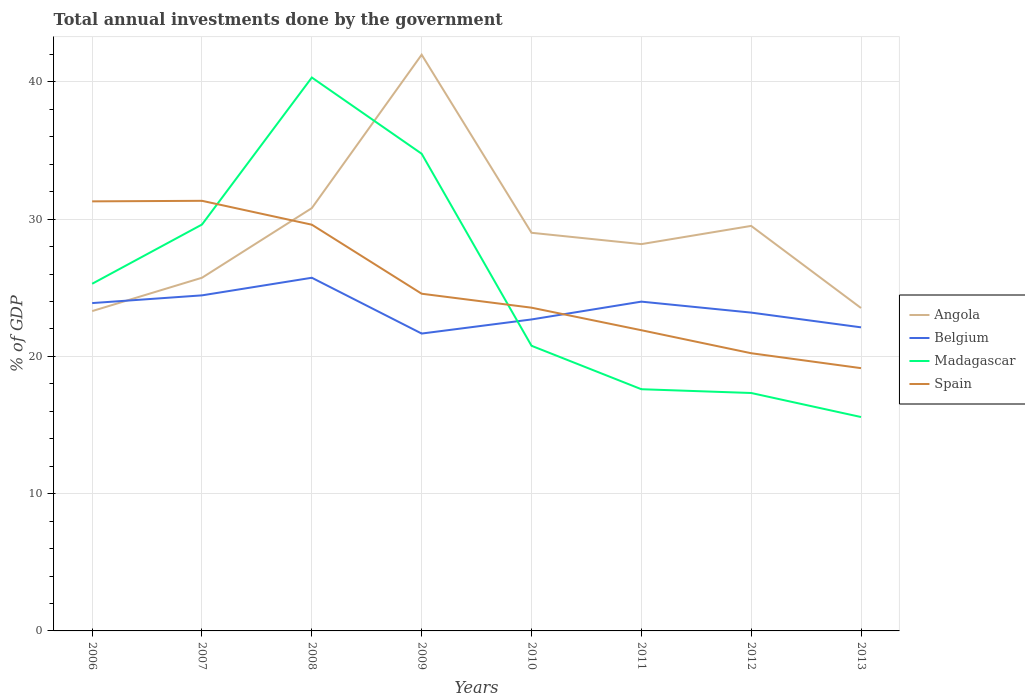How many different coloured lines are there?
Your answer should be compact. 4. Across all years, what is the maximum total annual investments done by the government in Belgium?
Offer a terse response. 21.66. In which year was the total annual investments done by the government in Belgium maximum?
Your answer should be compact. 2009. What is the total total annual investments done by the government in Belgium in the graph?
Make the answer very short. -0.45. What is the difference between the highest and the second highest total annual investments done by the government in Angola?
Your answer should be compact. 18.68. Is the total annual investments done by the government in Belgium strictly greater than the total annual investments done by the government in Spain over the years?
Provide a short and direct response. No. Are the values on the major ticks of Y-axis written in scientific E-notation?
Keep it short and to the point. No. Where does the legend appear in the graph?
Provide a short and direct response. Center right. How many legend labels are there?
Ensure brevity in your answer.  4. What is the title of the graph?
Your answer should be very brief. Total annual investments done by the government. Does "Cambodia" appear as one of the legend labels in the graph?
Provide a succinct answer. No. What is the label or title of the Y-axis?
Ensure brevity in your answer.  % of GDP. What is the % of GDP of Angola in 2006?
Give a very brief answer. 23.3. What is the % of GDP of Belgium in 2006?
Make the answer very short. 23.88. What is the % of GDP of Madagascar in 2006?
Your response must be concise. 25.29. What is the % of GDP of Spain in 2006?
Provide a succinct answer. 31.3. What is the % of GDP of Angola in 2007?
Your response must be concise. 25.73. What is the % of GDP in Belgium in 2007?
Make the answer very short. 24.45. What is the % of GDP of Madagascar in 2007?
Provide a short and direct response. 29.61. What is the % of GDP of Spain in 2007?
Provide a short and direct response. 31.34. What is the % of GDP in Angola in 2008?
Ensure brevity in your answer.  30.8. What is the % of GDP in Belgium in 2008?
Give a very brief answer. 25.73. What is the % of GDP of Madagascar in 2008?
Keep it short and to the point. 40.32. What is the % of GDP of Spain in 2008?
Give a very brief answer. 29.6. What is the % of GDP in Angola in 2009?
Your answer should be very brief. 41.98. What is the % of GDP in Belgium in 2009?
Offer a very short reply. 21.66. What is the % of GDP in Madagascar in 2009?
Your answer should be compact. 34.76. What is the % of GDP of Spain in 2009?
Ensure brevity in your answer.  24.57. What is the % of GDP in Angola in 2010?
Your answer should be compact. 29.01. What is the % of GDP of Belgium in 2010?
Ensure brevity in your answer.  22.69. What is the % of GDP of Madagascar in 2010?
Your answer should be very brief. 20.77. What is the % of GDP of Spain in 2010?
Your answer should be very brief. 23.55. What is the % of GDP of Angola in 2011?
Your response must be concise. 28.18. What is the % of GDP of Belgium in 2011?
Offer a very short reply. 23.99. What is the % of GDP of Madagascar in 2011?
Your response must be concise. 17.61. What is the % of GDP in Spain in 2011?
Your answer should be very brief. 21.91. What is the % of GDP in Angola in 2012?
Give a very brief answer. 29.51. What is the % of GDP in Belgium in 2012?
Ensure brevity in your answer.  23.19. What is the % of GDP of Madagascar in 2012?
Offer a terse response. 17.33. What is the % of GDP in Spain in 2012?
Offer a terse response. 20.23. What is the % of GDP of Angola in 2013?
Ensure brevity in your answer.  23.53. What is the % of GDP in Belgium in 2013?
Your response must be concise. 22.12. What is the % of GDP of Madagascar in 2013?
Your response must be concise. 15.58. What is the % of GDP of Spain in 2013?
Give a very brief answer. 19.14. Across all years, what is the maximum % of GDP of Angola?
Your response must be concise. 41.98. Across all years, what is the maximum % of GDP in Belgium?
Keep it short and to the point. 25.73. Across all years, what is the maximum % of GDP of Madagascar?
Ensure brevity in your answer.  40.32. Across all years, what is the maximum % of GDP in Spain?
Provide a short and direct response. 31.34. Across all years, what is the minimum % of GDP in Angola?
Your answer should be compact. 23.3. Across all years, what is the minimum % of GDP in Belgium?
Give a very brief answer. 21.66. Across all years, what is the minimum % of GDP of Madagascar?
Offer a very short reply. 15.58. Across all years, what is the minimum % of GDP in Spain?
Make the answer very short. 19.14. What is the total % of GDP of Angola in the graph?
Ensure brevity in your answer.  232.04. What is the total % of GDP in Belgium in the graph?
Your answer should be very brief. 187.72. What is the total % of GDP in Madagascar in the graph?
Make the answer very short. 201.28. What is the total % of GDP in Spain in the graph?
Give a very brief answer. 201.63. What is the difference between the % of GDP of Angola in 2006 and that in 2007?
Make the answer very short. -2.43. What is the difference between the % of GDP in Belgium in 2006 and that in 2007?
Offer a very short reply. -0.56. What is the difference between the % of GDP in Madagascar in 2006 and that in 2007?
Provide a succinct answer. -4.32. What is the difference between the % of GDP in Spain in 2006 and that in 2007?
Keep it short and to the point. -0.04. What is the difference between the % of GDP of Angola in 2006 and that in 2008?
Your response must be concise. -7.5. What is the difference between the % of GDP in Belgium in 2006 and that in 2008?
Provide a succinct answer. -1.85. What is the difference between the % of GDP in Madagascar in 2006 and that in 2008?
Provide a succinct answer. -15.03. What is the difference between the % of GDP in Spain in 2006 and that in 2008?
Offer a terse response. 1.7. What is the difference between the % of GDP of Angola in 2006 and that in 2009?
Keep it short and to the point. -18.68. What is the difference between the % of GDP in Belgium in 2006 and that in 2009?
Make the answer very short. 2.22. What is the difference between the % of GDP of Madagascar in 2006 and that in 2009?
Offer a terse response. -9.47. What is the difference between the % of GDP of Spain in 2006 and that in 2009?
Make the answer very short. 6.73. What is the difference between the % of GDP of Angola in 2006 and that in 2010?
Provide a succinct answer. -5.7. What is the difference between the % of GDP in Belgium in 2006 and that in 2010?
Keep it short and to the point. 1.19. What is the difference between the % of GDP in Madagascar in 2006 and that in 2010?
Keep it short and to the point. 4.52. What is the difference between the % of GDP in Spain in 2006 and that in 2010?
Your answer should be compact. 7.75. What is the difference between the % of GDP in Angola in 2006 and that in 2011?
Make the answer very short. -4.88. What is the difference between the % of GDP of Belgium in 2006 and that in 2011?
Provide a succinct answer. -0.11. What is the difference between the % of GDP of Madagascar in 2006 and that in 2011?
Make the answer very short. 7.68. What is the difference between the % of GDP of Spain in 2006 and that in 2011?
Give a very brief answer. 9.39. What is the difference between the % of GDP of Angola in 2006 and that in 2012?
Offer a terse response. -6.21. What is the difference between the % of GDP of Belgium in 2006 and that in 2012?
Provide a short and direct response. 0.69. What is the difference between the % of GDP in Madagascar in 2006 and that in 2012?
Provide a succinct answer. 7.96. What is the difference between the % of GDP of Spain in 2006 and that in 2012?
Keep it short and to the point. 11.06. What is the difference between the % of GDP in Angola in 2006 and that in 2013?
Offer a very short reply. -0.22. What is the difference between the % of GDP in Belgium in 2006 and that in 2013?
Give a very brief answer. 1.77. What is the difference between the % of GDP of Madagascar in 2006 and that in 2013?
Your answer should be very brief. 9.71. What is the difference between the % of GDP of Spain in 2006 and that in 2013?
Offer a very short reply. 12.15. What is the difference between the % of GDP of Angola in 2007 and that in 2008?
Give a very brief answer. -5.07. What is the difference between the % of GDP of Belgium in 2007 and that in 2008?
Give a very brief answer. -1.28. What is the difference between the % of GDP of Madagascar in 2007 and that in 2008?
Ensure brevity in your answer.  -10.71. What is the difference between the % of GDP in Spain in 2007 and that in 2008?
Offer a terse response. 1.74. What is the difference between the % of GDP in Angola in 2007 and that in 2009?
Ensure brevity in your answer.  -16.25. What is the difference between the % of GDP of Belgium in 2007 and that in 2009?
Offer a terse response. 2.78. What is the difference between the % of GDP in Madagascar in 2007 and that in 2009?
Offer a very short reply. -5.16. What is the difference between the % of GDP of Spain in 2007 and that in 2009?
Offer a terse response. 6.77. What is the difference between the % of GDP in Angola in 2007 and that in 2010?
Your answer should be compact. -3.27. What is the difference between the % of GDP of Belgium in 2007 and that in 2010?
Your answer should be compact. 1.76. What is the difference between the % of GDP in Madagascar in 2007 and that in 2010?
Offer a very short reply. 8.83. What is the difference between the % of GDP of Spain in 2007 and that in 2010?
Provide a succinct answer. 7.79. What is the difference between the % of GDP of Angola in 2007 and that in 2011?
Make the answer very short. -2.45. What is the difference between the % of GDP of Belgium in 2007 and that in 2011?
Keep it short and to the point. 0.46. What is the difference between the % of GDP of Madagascar in 2007 and that in 2011?
Provide a succinct answer. 12. What is the difference between the % of GDP in Spain in 2007 and that in 2011?
Ensure brevity in your answer.  9.43. What is the difference between the % of GDP in Angola in 2007 and that in 2012?
Keep it short and to the point. -3.78. What is the difference between the % of GDP in Belgium in 2007 and that in 2012?
Keep it short and to the point. 1.26. What is the difference between the % of GDP of Madagascar in 2007 and that in 2012?
Provide a short and direct response. 12.27. What is the difference between the % of GDP in Spain in 2007 and that in 2012?
Provide a short and direct response. 11.1. What is the difference between the % of GDP in Angola in 2007 and that in 2013?
Offer a terse response. 2.21. What is the difference between the % of GDP of Belgium in 2007 and that in 2013?
Provide a short and direct response. 2.33. What is the difference between the % of GDP in Madagascar in 2007 and that in 2013?
Your response must be concise. 14.02. What is the difference between the % of GDP in Spain in 2007 and that in 2013?
Provide a succinct answer. 12.19. What is the difference between the % of GDP of Angola in 2008 and that in 2009?
Give a very brief answer. -11.18. What is the difference between the % of GDP in Belgium in 2008 and that in 2009?
Keep it short and to the point. 4.07. What is the difference between the % of GDP of Madagascar in 2008 and that in 2009?
Your response must be concise. 5.55. What is the difference between the % of GDP of Spain in 2008 and that in 2009?
Your answer should be compact. 5.03. What is the difference between the % of GDP in Angola in 2008 and that in 2010?
Ensure brevity in your answer.  1.8. What is the difference between the % of GDP of Belgium in 2008 and that in 2010?
Offer a terse response. 3.04. What is the difference between the % of GDP of Madagascar in 2008 and that in 2010?
Provide a succinct answer. 19.54. What is the difference between the % of GDP in Spain in 2008 and that in 2010?
Your answer should be compact. 6.05. What is the difference between the % of GDP of Angola in 2008 and that in 2011?
Make the answer very short. 2.62. What is the difference between the % of GDP in Belgium in 2008 and that in 2011?
Your answer should be very brief. 1.74. What is the difference between the % of GDP of Madagascar in 2008 and that in 2011?
Keep it short and to the point. 22.71. What is the difference between the % of GDP in Spain in 2008 and that in 2011?
Provide a succinct answer. 7.69. What is the difference between the % of GDP in Angola in 2008 and that in 2012?
Provide a short and direct response. 1.3. What is the difference between the % of GDP of Belgium in 2008 and that in 2012?
Give a very brief answer. 2.54. What is the difference between the % of GDP of Madagascar in 2008 and that in 2012?
Your response must be concise. 22.98. What is the difference between the % of GDP in Spain in 2008 and that in 2012?
Provide a succinct answer. 9.36. What is the difference between the % of GDP of Angola in 2008 and that in 2013?
Offer a very short reply. 7.28. What is the difference between the % of GDP in Belgium in 2008 and that in 2013?
Give a very brief answer. 3.61. What is the difference between the % of GDP of Madagascar in 2008 and that in 2013?
Provide a short and direct response. 24.73. What is the difference between the % of GDP of Spain in 2008 and that in 2013?
Offer a terse response. 10.45. What is the difference between the % of GDP in Angola in 2009 and that in 2010?
Offer a terse response. 12.98. What is the difference between the % of GDP in Belgium in 2009 and that in 2010?
Your answer should be compact. -1.03. What is the difference between the % of GDP in Madagascar in 2009 and that in 2010?
Your answer should be very brief. 13.99. What is the difference between the % of GDP in Spain in 2009 and that in 2010?
Offer a terse response. 1.02. What is the difference between the % of GDP of Angola in 2009 and that in 2011?
Your answer should be very brief. 13.8. What is the difference between the % of GDP in Belgium in 2009 and that in 2011?
Your answer should be compact. -2.33. What is the difference between the % of GDP in Madagascar in 2009 and that in 2011?
Give a very brief answer. 17.16. What is the difference between the % of GDP in Spain in 2009 and that in 2011?
Ensure brevity in your answer.  2.66. What is the difference between the % of GDP of Angola in 2009 and that in 2012?
Provide a short and direct response. 12.47. What is the difference between the % of GDP of Belgium in 2009 and that in 2012?
Keep it short and to the point. -1.53. What is the difference between the % of GDP in Madagascar in 2009 and that in 2012?
Offer a terse response. 17.43. What is the difference between the % of GDP in Spain in 2009 and that in 2012?
Make the answer very short. 4.33. What is the difference between the % of GDP in Angola in 2009 and that in 2013?
Give a very brief answer. 18.46. What is the difference between the % of GDP in Belgium in 2009 and that in 2013?
Keep it short and to the point. -0.45. What is the difference between the % of GDP in Madagascar in 2009 and that in 2013?
Your response must be concise. 19.18. What is the difference between the % of GDP in Spain in 2009 and that in 2013?
Ensure brevity in your answer.  5.42. What is the difference between the % of GDP of Angola in 2010 and that in 2011?
Your answer should be very brief. 0.83. What is the difference between the % of GDP in Belgium in 2010 and that in 2011?
Offer a terse response. -1.3. What is the difference between the % of GDP in Madagascar in 2010 and that in 2011?
Offer a very short reply. 3.17. What is the difference between the % of GDP of Spain in 2010 and that in 2011?
Your answer should be very brief. 1.64. What is the difference between the % of GDP in Angola in 2010 and that in 2012?
Provide a short and direct response. -0.5. What is the difference between the % of GDP of Belgium in 2010 and that in 2012?
Provide a short and direct response. -0.5. What is the difference between the % of GDP of Madagascar in 2010 and that in 2012?
Give a very brief answer. 3.44. What is the difference between the % of GDP in Spain in 2010 and that in 2012?
Offer a very short reply. 3.32. What is the difference between the % of GDP in Angola in 2010 and that in 2013?
Make the answer very short. 5.48. What is the difference between the % of GDP in Belgium in 2010 and that in 2013?
Make the answer very short. 0.57. What is the difference between the % of GDP of Madagascar in 2010 and that in 2013?
Ensure brevity in your answer.  5.19. What is the difference between the % of GDP of Spain in 2010 and that in 2013?
Your response must be concise. 4.41. What is the difference between the % of GDP of Angola in 2011 and that in 2012?
Your answer should be compact. -1.33. What is the difference between the % of GDP in Belgium in 2011 and that in 2012?
Provide a short and direct response. 0.8. What is the difference between the % of GDP in Madagascar in 2011 and that in 2012?
Keep it short and to the point. 0.28. What is the difference between the % of GDP in Spain in 2011 and that in 2012?
Offer a terse response. 1.68. What is the difference between the % of GDP in Angola in 2011 and that in 2013?
Offer a terse response. 4.65. What is the difference between the % of GDP in Belgium in 2011 and that in 2013?
Your answer should be very brief. 1.87. What is the difference between the % of GDP of Madagascar in 2011 and that in 2013?
Offer a very short reply. 2.03. What is the difference between the % of GDP of Spain in 2011 and that in 2013?
Give a very brief answer. 2.76. What is the difference between the % of GDP of Angola in 2012 and that in 2013?
Ensure brevity in your answer.  5.98. What is the difference between the % of GDP of Belgium in 2012 and that in 2013?
Make the answer very short. 1.07. What is the difference between the % of GDP of Madagascar in 2012 and that in 2013?
Give a very brief answer. 1.75. What is the difference between the % of GDP in Spain in 2012 and that in 2013?
Your answer should be very brief. 1.09. What is the difference between the % of GDP of Angola in 2006 and the % of GDP of Belgium in 2007?
Ensure brevity in your answer.  -1.15. What is the difference between the % of GDP of Angola in 2006 and the % of GDP of Madagascar in 2007?
Your answer should be compact. -6.31. What is the difference between the % of GDP in Angola in 2006 and the % of GDP in Spain in 2007?
Your answer should be very brief. -8.03. What is the difference between the % of GDP of Belgium in 2006 and the % of GDP of Madagascar in 2007?
Give a very brief answer. -5.72. What is the difference between the % of GDP of Belgium in 2006 and the % of GDP of Spain in 2007?
Your response must be concise. -7.45. What is the difference between the % of GDP of Madagascar in 2006 and the % of GDP of Spain in 2007?
Keep it short and to the point. -6.04. What is the difference between the % of GDP of Angola in 2006 and the % of GDP of Belgium in 2008?
Keep it short and to the point. -2.43. What is the difference between the % of GDP of Angola in 2006 and the % of GDP of Madagascar in 2008?
Provide a succinct answer. -17.02. What is the difference between the % of GDP of Angola in 2006 and the % of GDP of Spain in 2008?
Your response must be concise. -6.3. What is the difference between the % of GDP in Belgium in 2006 and the % of GDP in Madagascar in 2008?
Your answer should be very brief. -16.43. What is the difference between the % of GDP of Belgium in 2006 and the % of GDP of Spain in 2008?
Offer a very short reply. -5.71. What is the difference between the % of GDP in Madagascar in 2006 and the % of GDP in Spain in 2008?
Make the answer very short. -4.3. What is the difference between the % of GDP in Angola in 2006 and the % of GDP in Belgium in 2009?
Offer a very short reply. 1.64. What is the difference between the % of GDP in Angola in 2006 and the % of GDP in Madagascar in 2009?
Give a very brief answer. -11.46. What is the difference between the % of GDP in Angola in 2006 and the % of GDP in Spain in 2009?
Make the answer very short. -1.26. What is the difference between the % of GDP in Belgium in 2006 and the % of GDP in Madagascar in 2009?
Your response must be concise. -10.88. What is the difference between the % of GDP of Belgium in 2006 and the % of GDP of Spain in 2009?
Offer a very short reply. -0.68. What is the difference between the % of GDP in Madagascar in 2006 and the % of GDP in Spain in 2009?
Your answer should be very brief. 0.73. What is the difference between the % of GDP of Angola in 2006 and the % of GDP of Belgium in 2010?
Keep it short and to the point. 0.61. What is the difference between the % of GDP in Angola in 2006 and the % of GDP in Madagascar in 2010?
Your response must be concise. 2.53. What is the difference between the % of GDP in Angola in 2006 and the % of GDP in Spain in 2010?
Keep it short and to the point. -0.25. What is the difference between the % of GDP in Belgium in 2006 and the % of GDP in Madagascar in 2010?
Offer a terse response. 3.11. What is the difference between the % of GDP in Belgium in 2006 and the % of GDP in Spain in 2010?
Make the answer very short. 0.33. What is the difference between the % of GDP in Madagascar in 2006 and the % of GDP in Spain in 2010?
Offer a terse response. 1.74. What is the difference between the % of GDP of Angola in 2006 and the % of GDP of Belgium in 2011?
Your answer should be very brief. -0.69. What is the difference between the % of GDP in Angola in 2006 and the % of GDP in Madagascar in 2011?
Offer a very short reply. 5.69. What is the difference between the % of GDP in Angola in 2006 and the % of GDP in Spain in 2011?
Keep it short and to the point. 1.39. What is the difference between the % of GDP of Belgium in 2006 and the % of GDP of Madagascar in 2011?
Provide a succinct answer. 6.28. What is the difference between the % of GDP in Belgium in 2006 and the % of GDP in Spain in 2011?
Ensure brevity in your answer.  1.98. What is the difference between the % of GDP in Madagascar in 2006 and the % of GDP in Spain in 2011?
Make the answer very short. 3.38. What is the difference between the % of GDP of Angola in 2006 and the % of GDP of Belgium in 2012?
Keep it short and to the point. 0.11. What is the difference between the % of GDP of Angola in 2006 and the % of GDP of Madagascar in 2012?
Give a very brief answer. 5.97. What is the difference between the % of GDP of Angola in 2006 and the % of GDP of Spain in 2012?
Your answer should be compact. 3.07. What is the difference between the % of GDP in Belgium in 2006 and the % of GDP in Madagascar in 2012?
Your response must be concise. 6.55. What is the difference between the % of GDP of Belgium in 2006 and the % of GDP of Spain in 2012?
Ensure brevity in your answer.  3.65. What is the difference between the % of GDP of Madagascar in 2006 and the % of GDP of Spain in 2012?
Your answer should be compact. 5.06. What is the difference between the % of GDP in Angola in 2006 and the % of GDP in Belgium in 2013?
Offer a very short reply. 1.18. What is the difference between the % of GDP in Angola in 2006 and the % of GDP in Madagascar in 2013?
Your answer should be very brief. 7.72. What is the difference between the % of GDP of Angola in 2006 and the % of GDP of Spain in 2013?
Give a very brief answer. 4.16. What is the difference between the % of GDP in Belgium in 2006 and the % of GDP in Madagascar in 2013?
Your response must be concise. 8.3. What is the difference between the % of GDP in Belgium in 2006 and the % of GDP in Spain in 2013?
Offer a very short reply. 4.74. What is the difference between the % of GDP of Madagascar in 2006 and the % of GDP of Spain in 2013?
Offer a terse response. 6.15. What is the difference between the % of GDP of Angola in 2007 and the % of GDP of Madagascar in 2008?
Ensure brevity in your answer.  -14.59. What is the difference between the % of GDP in Angola in 2007 and the % of GDP in Spain in 2008?
Provide a short and direct response. -3.87. What is the difference between the % of GDP of Belgium in 2007 and the % of GDP of Madagascar in 2008?
Your response must be concise. -15.87. What is the difference between the % of GDP of Belgium in 2007 and the % of GDP of Spain in 2008?
Make the answer very short. -5.15. What is the difference between the % of GDP of Madagascar in 2007 and the % of GDP of Spain in 2008?
Your response must be concise. 0.01. What is the difference between the % of GDP of Angola in 2007 and the % of GDP of Belgium in 2009?
Provide a succinct answer. 4.07. What is the difference between the % of GDP of Angola in 2007 and the % of GDP of Madagascar in 2009?
Give a very brief answer. -9.03. What is the difference between the % of GDP in Angola in 2007 and the % of GDP in Spain in 2009?
Keep it short and to the point. 1.16. What is the difference between the % of GDP in Belgium in 2007 and the % of GDP in Madagascar in 2009?
Keep it short and to the point. -10.32. What is the difference between the % of GDP of Belgium in 2007 and the % of GDP of Spain in 2009?
Make the answer very short. -0.12. What is the difference between the % of GDP in Madagascar in 2007 and the % of GDP in Spain in 2009?
Make the answer very short. 5.04. What is the difference between the % of GDP in Angola in 2007 and the % of GDP in Belgium in 2010?
Offer a terse response. 3.04. What is the difference between the % of GDP in Angola in 2007 and the % of GDP in Madagascar in 2010?
Offer a very short reply. 4.96. What is the difference between the % of GDP in Angola in 2007 and the % of GDP in Spain in 2010?
Keep it short and to the point. 2.18. What is the difference between the % of GDP of Belgium in 2007 and the % of GDP of Madagascar in 2010?
Offer a very short reply. 3.67. What is the difference between the % of GDP in Belgium in 2007 and the % of GDP in Spain in 2010?
Keep it short and to the point. 0.9. What is the difference between the % of GDP in Madagascar in 2007 and the % of GDP in Spain in 2010?
Provide a short and direct response. 6.06. What is the difference between the % of GDP in Angola in 2007 and the % of GDP in Belgium in 2011?
Offer a terse response. 1.74. What is the difference between the % of GDP of Angola in 2007 and the % of GDP of Madagascar in 2011?
Make the answer very short. 8.12. What is the difference between the % of GDP in Angola in 2007 and the % of GDP in Spain in 2011?
Provide a succinct answer. 3.82. What is the difference between the % of GDP in Belgium in 2007 and the % of GDP in Madagascar in 2011?
Provide a short and direct response. 6.84. What is the difference between the % of GDP of Belgium in 2007 and the % of GDP of Spain in 2011?
Your response must be concise. 2.54. What is the difference between the % of GDP in Madagascar in 2007 and the % of GDP in Spain in 2011?
Make the answer very short. 7.7. What is the difference between the % of GDP in Angola in 2007 and the % of GDP in Belgium in 2012?
Offer a terse response. 2.54. What is the difference between the % of GDP of Angola in 2007 and the % of GDP of Madagascar in 2012?
Your response must be concise. 8.4. What is the difference between the % of GDP in Angola in 2007 and the % of GDP in Spain in 2012?
Your answer should be compact. 5.5. What is the difference between the % of GDP in Belgium in 2007 and the % of GDP in Madagascar in 2012?
Keep it short and to the point. 7.11. What is the difference between the % of GDP in Belgium in 2007 and the % of GDP in Spain in 2012?
Ensure brevity in your answer.  4.22. What is the difference between the % of GDP of Madagascar in 2007 and the % of GDP of Spain in 2012?
Make the answer very short. 9.38. What is the difference between the % of GDP of Angola in 2007 and the % of GDP of Belgium in 2013?
Your response must be concise. 3.61. What is the difference between the % of GDP of Angola in 2007 and the % of GDP of Madagascar in 2013?
Your response must be concise. 10.15. What is the difference between the % of GDP in Angola in 2007 and the % of GDP in Spain in 2013?
Keep it short and to the point. 6.59. What is the difference between the % of GDP of Belgium in 2007 and the % of GDP of Madagascar in 2013?
Offer a very short reply. 8.86. What is the difference between the % of GDP of Belgium in 2007 and the % of GDP of Spain in 2013?
Ensure brevity in your answer.  5.3. What is the difference between the % of GDP of Madagascar in 2007 and the % of GDP of Spain in 2013?
Provide a succinct answer. 10.46. What is the difference between the % of GDP of Angola in 2008 and the % of GDP of Belgium in 2009?
Your answer should be very brief. 9.14. What is the difference between the % of GDP in Angola in 2008 and the % of GDP in Madagascar in 2009?
Provide a short and direct response. -3.96. What is the difference between the % of GDP of Angola in 2008 and the % of GDP of Spain in 2009?
Ensure brevity in your answer.  6.24. What is the difference between the % of GDP of Belgium in 2008 and the % of GDP of Madagascar in 2009?
Offer a terse response. -9.03. What is the difference between the % of GDP of Belgium in 2008 and the % of GDP of Spain in 2009?
Your answer should be very brief. 1.16. What is the difference between the % of GDP of Madagascar in 2008 and the % of GDP of Spain in 2009?
Your answer should be compact. 15.75. What is the difference between the % of GDP in Angola in 2008 and the % of GDP in Belgium in 2010?
Provide a succinct answer. 8.11. What is the difference between the % of GDP of Angola in 2008 and the % of GDP of Madagascar in 2010?
Offer a very short reply. 10.03. What is the difference between the % of GDP in Angola in 2008 and the % of GDP in Spain in 2010?
Make the answer very short. 7.25. What is the difference between the % of GDP of Belgium in 2008 and the % of GDP of Madagascar in 2010?
Give a very brief answer. 4.96. What is the difference between the % of GDP of Belgium in 2008 and the % of GDP of Spain in 2010?
Ensure brevity in your answer.  2.18. What is the difference between the % of GDP of Madagascar in 2008 and the % of GDP of Spain in 2010?
Give a very brief answer. 16.77. What is the difference between the % of GDP in Angola in 2008 and the % of GDP in Belgium in 2011?
Keep it short and to the point. 6.81. What is the difference between the % of GDP in Angola in 2008 and the % of GDP in Madagascar in 2011?
Ensure brevity in your answer.  13.19. What is the difference between the % of GDP of Angola in 2008 and the % of GDP of Spain in 2011?
Offer a terse response. 8.9. What is the difference between the % of GDP of Belgium in 2008 and the % of GDP of Madagascar in 2011?
Offer a very short reply. 8.12. What is the difference between the % of GDP of Belgium in 2008 and the % of GDP of Spain in 2011?
Your response must be concise. 3.82. What is the difference between the % of GDP of Madagascar in 2008 and the % of GDP of Spain in 2011?
Make the answer very short. 18.41. What is the difference between the % of GDP in Angola in 2008 and the % of GDP in Belgium in 2012?
Provide a short and direct response. 7.61. What is the difference between the % of GDP of Angola in 2008 and the % of GDP of Madagascar in 2012?
Offer a very short reply. 13.47. What is the difference between the % of GDP of Angola in 2008 and the % of GDP of Spain in 2012?
Your response must be concise. 10.57. What is the difference between the % of GDP in Belgium in 2008 and the % of GDP in Madagascar in 2012?
Your answer should be compact. 8.4. What is the difference between the % of GDP in Belgium in 2008 and the % of GDP in Spain in 2012?
Your answer should be very brief. 5.5. What is the difference between the % of GDP of Madagascar in 2008 and the % of GDP of Spain in 2012?
Make the answer very short. 20.09. What is the difference between the % of GDP of Angola in 2008 and the % of GDP of Belgium in 2013?
Keep it short and to the point. 8.69. What is the difference between the % of GDP in Angola in 2008 and the % of GDP in Madagascar in 2013?
Keep it short and to the point. 15.22. What is the difference between the % of GDP in Angola in 2008 and the % of GDP in Spain in 2013?
Your answer should be very brief. 11.66. What is the difference between the % of GDP in Belgium in 2008 and the % of GDP in Madagascar in 2013?
Provide a succinct answer. 10.15. What is the difference between the % of GDP in Belgium in 2008 and the % of GDP in Spain in 2013?
Your answer should be compact. 6.59. What is the difference between the % of GDP in Madagascar in 2008 and the % of GDP in Spain in 2013?
Offer a very short reply. 21.17. What is the difference between the % of GDP in Angola in 2009 and the % of GDP in Belgium in 2010?
Ensure brevity in your answer.  19.29. What is the difference between the % of GDP of Angola in 2009 and the % of GDP of Madagascar in 2010?
Your answer should be compact. 21.21. What is the difference between the % of GDP in Angola in 2009 and the % of GDP in Spain in 2010?
Offer a very short reply. 18.43. What is the difference between the % of GDP in Belgium in 2009 and the % of GDP in Madagascar in 2010?
Offer a very short reply. 0.89. What is the difference between the % of GDP of Belgium in 2009 and the % of GDP of Spain in 2010?
Your answer should be very brief. -1.89. What is the difference between the % of GDP of Madagascar in 2009 and the % of GDP of Spain in 2010?
Offer a terse response. 11.21. What is the difference between the % of GDP in Angola in 2009 and the % of GDP in Belgium in 2011?
Ensure brevity in your answer.  17.99. What is the difference between the % of GDP in Angola in 2009 and the % of GDP in Madagascar in 2011?
Ensure brevity in your answer.  24.37. What is the difference between the % of GDP of Angola in 2009 and the % of GDP of Spain in 2011?
Provide a succinct answer. 20.07. What is the difference between the % of GDP in Belgium in 2009 and the % of GDP in Madagascar in 2011?
Offer a very short reply. 4.06. What is the difference between the % of GDP of Belgium in 2009 and the % of GDP of Spain in 2011?
Your answer should be compact. -0.24. What is the difference between the % of GDP in Madagascar in 2009 and the % of GDP in Spain in 2011?
Keep it short and to the point. 12.86. What is the difference between the % of GDP in Angola in 2009 and the % of GDP in Belgium in 2012?
Offer a terse response. 18.79. What is the difference between the % of GDP of Angola in 2009 and the % of GDP of Madagascar in 2012?
Keep it short and to the point. 24.65. What is the difference between the % of GDP in Angola in 2009 and the % of GDP in Spain in 2012?
Make the answer very short. 21.75. What is the difference between the % of GDP in Belgium in 2009 and the % of GDP in Madagascar in 2012?
Provide a succinct answer. 4.33. What is the difference between the % of GDP of Belgium in 2009 and the % of GDP of Spain in 2012?
Ensure brevity in your answer.  1.43. What is the difference between the % of GDP of Madagascar in 2009 and the % of GDP of Spain in 2012?
Give a very brief answer. 14.53. What is the difference between the % of GDP in Angola in 2009 and the % of GDP in Belgium in 2013?
Provide a succinct answer. 19.86. What is the difference between the % of GDP of Angola in 2009 and the % of GDP of Madagascar in 2013?
Provide a succinct answer. 26.4. What is the difference between the % of GDP of Angola in 2009 and the % of GDP of Spain in 2013?
Keep it short and to the point. 22.84. What is the difference between the % of GDP in Belgium in 2009 and the % of GDP in Madagascar in 2013?
Ensure brevity in your answer.  6.08. What is the difference between the % of GDP in Belgium in 2009 and the % of GDP in Spain in 2013?
Make the answer very short. 2.52. What is the difference between the % of GDP of Madagascar in 2009 and the % of GDP of Spain in 2013?
Make the answer very short. 15.62. What is the difference between the % of GDP in Angola in 2010 and the % of GDP in Belgium in 2011?
Provide a short and direct response. 5.02. What is the difference between the % of GDP of Angola in 2010 and the % of GDP of Madagascar in 2011?
Make the answer very short. 11.4. What is the difference between the % of GDP of Angola in 2010 and the % of GDP of Spain in 2011?
Your response must be concise. 7.1. What is the difference between the % of GDP of Belgium in 2010 and the % of GDP of Madagascar in 2011?
Your response must be concise. 5.08. What is the difference between the % of GDP of Belgium in 2010 and the % of GDP of Spain in 2011?
Provide a succinct answer. 0.78. What is the difference between the % of GDP of Madagascar in 2010 and the % of GDP of Spain in 2011?
Ensure brevity in your answer.  -1.13. What is the difference between the % of GDP of Angola in 2010 and the % of GDP of Belgium in 2012?
Keep it short and to the point. 5.81. What is the difference between the % of GDP of Angola in 2010 and the % of GDP of Madagascar in 2012?
Your answer should be compact. 11.67. What is the difference between the % of GDP in Angola in 2010 and the % of GDP in Spain in 2012?
Give a very brief answer. 8.77. What is the difference between the % of GDP of Belgium in 2010 and the % of GDP of Madagascar in 2012?
Ensure brevity in your answer.  5.36. What is the difference between the % of GDP of Belgium in 2010 and the % of GDP of Spain in 2012?
Ensure brevity in your answer.  2.46. What is the difference between the % of GDP in Madagascar in 2010 and the % of GDP in Spain in 2012?
Give a very brief answer. 0.54. What is the difference between the % of GDP in Angola in 2010 and the % of GDP in Belgium in 2013?
Offer a very short reply. 6.89. What is the difference between the % of GDP in Angola in 2010 and the % of GDP in Madagascar in 2013?
Your answer should be compact. 13.42. What is the difference between the % of GDP of Angola in 2010 and the % of GDP of Spain in 2013?
Your answer should be compact. 9.86. What is the difference between the % of GDP in Belgium in 2010 and the % of GDP in Madagascar in 2013?
Provide a succinct answer. 7.11. What is the difference between the % of GDP of Belgium in 2010 and the % of GDP of Spain in 2013?
Your answer should be compact. 3.55. What is the difference between the % of GDP in Madagascar in 2010 and the % of GDP in Spain in 2013?
Provide a succinct answer. 1.63. What is the difference between the % of GDP of Angola in 2011 and the % of GDP of Belgium in 2012?
Offer a terse response. 4.99. What is the difference between the % of GDP in Angola in 2011 and the % of GDP in Madagascar in 2012?
Provide a succinct answer. 10.85. What is the difference between the % of GDP in Angola in 2011 and the % of GDP in Spain in 2012?
Your answer should be compact. 7.95. What is the difference between the % of GDP in Belgium in 2011 and the % of GDP in Madagascar in 2012?
Ensure brevity in your answer.  6.66. What is the difference between the % of GDP of Belgium in 2011 and the % of GDP of Spain in 2012?
Keep it short and to the point. 3.76. What is the difference between the % of GDP in Madagascar in 2011 and the % of GDP in Spain in 2012?
Your answer should be compact. -2.62. What is the difference between the % of GDP of Angola in 2011 and the % of GDP of Belgium in 2013?
Your answer should be very brief. 6.06. What is the difference between the % of GDP in Angola in 2011 and the % of GDP in Madagascar in 2013?
Make the answer very short. 12.6. What is the difference between the % of GDP in Angola in 2011 and the % of GDP in Spain in 2013?
Offer a terse response. 9.04. What is the difference between the % of GDP in Belgium in 2011 and the % of GDP in Madagascar in 2013?
Provide a short and direct response. 8.41. What is the difference between the % of GDP of Belgium in 2011 and the % of GDP of Spain in 2013?
Ensure brevity in your answer.  4.85. What is the difference between the % of GDP of Madagascar in 2011 and the % of GDP of Spain in 2013?
Make the answer very short. -1.53. What is the difference between the % of GDP in Angola in 2012 and the % of GDP in Belgium in 2013?
Keep it short and to the point. 7.39. What is the difference between the % of GDP of Angola in 2012 and the % of GDP of Madagascar in 2013?
Offer a terse response. 13.92. What is the difference between the % of GDP of Angola in 2012 and the % of GDP of Spain in 2013?
Keep it short and to the point. 10.36. What is the difference between the % of GDP of Belgium in 2012 and the % of GDP of Madagascar in 2013?
Offer a terse response. 7.61. What is the difference between the % of GDP in Belgium in 2012 and the % of GDP in Spain in 2013?
Provide a short and direct response. 4.05. What is the difference between the % of GDP of Madagascar in 2012 and the % of GDP of Spain in 2013?
Offer a terse response. -1.81. What is the average % of GDP of Angola per year?
Provide a short and direct response. 29. What is the average % of GDP of Belgium per year?
Your response must be concise. 23.46. What is the average % of GDP in Madagascar per year?
Your answer should be very brief. 25.16. What is the average % of GDP in Spain per year?
Your answer should be very brief. 25.2. In the year 2006, what is the difference between the % of GDP in Angola and % of GDP in Belgium?
Give a very brief answer. -0.58. In the year 2006, what is the difference between the % of GDP of Angola and % of GDP of Madagascar?
Give a very brief answer. -1.99. In the year 2006, what is the difference between the % of GDP in Angola and % of GDP in Spain?
Offer a very short reply. -8. In the year 2006, what is the difference between the % of GDP of Belgium and % of GDP of Madagascar?
Your response must be concise. -1.41. In the year 2006, what is the difference between the % of GDP in Belgium and % of GDP in Spain?
Your response must be concise. -7.41. In the year 2006, what is the difference between the % of GDP in Madagascar and % of GDP in Spain?
Ensure brevity in your answer.  -6. In the year 2007, what is the difference between the % of GDP in Angola and % of GDP in Belgium?
Your answer should be compact. 1.28. In the year 2007, what is the difference between the % of GDP of Angola and % of GDP of Madagascar?
Ensure brevity in your answer.  -3.88. In the year 2007, what is the difference between the % of GDP in Angola and % of GDP in Spain?
Give a very brief answer. -5.6. In the year 2007, what is the difference between the % of GDP in Belgium and % of GDP in Madagascar?
Make the answer very short. -5.16. In the year 2007, what is the difference between the % of GDP of Belgium and % of GDP of Spain?
Ensure brevity in your answer.  -6.89. In the year 2007, what is the difference between the % of GDP in Madagascar and % of GDP in Spain?
Keep it short and to the point. -1.73. In the year 2008, what is the difference between the % of GDP of Angola and % of GDP of Belgium?
Make the answer very short. 5.07. In the year 2008, what is the difference between the % of GDP in Angola and % of GDP in Madagascar?
Your answer should be very brief. -9.51. In the year 2008, what is the difference between the % of GDP of Angola and % of GDP of Spain?
Provide a short and direct response. 1.21. In the year 2008, what is the difference between the % of GDP of Belgium and % of GDP of Madagascar?
Your response must be concise. -14.59. In the year 2008, what is the difference between the % of GDP of Belgium and % of GDP of Spain?
Your answer should be compact. -3.87. In the year 2008, what is the difference between the % of GDP in Madagascar and % of GDP in Spain?
Offer a very short reply. 10.72. In the year 2009, what is the difference between the % of GDP of Angola and % of GDP of Belgium?
Provide a short and direct response. 20.32. In the year 2009, what is the difference between the % of GDP in Angola and % of GDP in Madagascar?
Your response must be concise. 7.22. In the year 2009, what is the difference between the % of GDP of Angola and % of GDP of Spain?
Your answer should be very brief. 17.42. In the year 2009, what is the difference between the % of GDP of Belgium and % of GDP of Madagascar?
Your answer should be very brief. -13.1. In the year 2009, what is the difference between the % of GDP of Belgium and % of GDP of Spain?
Provide a succinct answer. -2.9. In the year 2009, what is the difference between the % of GDP of Madagascar and % of GDP of Spain?
Provide a succinct answer. 10.2. In the year 2010, what is the difference between the % of GDP in Angola and % of GDP in Belgium?
Your response must be concise. 6.31. In the year 2010, what is the difference between the % of GDP in Angola and % of GDP in Madagascar?
Provide a succinct answer. 8.23. In the year 2010, what is the difference between the % of GDP in Angola and % of GDP in Spain?
Provide a short and direct response. 5.46. In the year 2010, what is the difference between the % of GDP in Belgium and % of GDP in Madagascar?
Keep it short and to the point. 1.92. In the year 2010, what is the difference between the % of GDP of Belgium and % of GDP of Spain?
Offer a terse response. -0.86. In the year 2010, what is the difference between the % of GDP in Madagascar and % of GDP in Spain?
Ensure brevity in your answer.  -2.77. In the year 2011, what is the difference between the % of GDP in Angola and % of GDP in Belgium?
Provide a succinct answer. 4.19. In the year 2011, what is the difference between the % of GDP in Angola and % of GDP in Madagascar?
Provide a succinct answer. 10.57. In the year 2011, what is the difference between the % of GDP in Angola and % of GDP in Spain?
Give a very brief answer. 6.27. In the year 2011, what is the difference between the % of GDP of Belgium and % of GDP of Madagascar?
Provide a short and direct response. 6.38. In the year 2011, what is the difference between the % of GDP of Belgium and % of GDP of Spain?
Make the answer very short. 2.08. In the year 2011, what is the difference between the % of GDP of Madagascar and % of GDP of Spain?
Keep it short and to the point. -4.3. In the year 2012, what is the difference between the % of GDP in Angola and % of GDP in Belgium?
Keep it short and to the point. 6.32. In the year 2012, what is the difference between the % of GDP in Angola and % of GDP in Madagascar?
Provide a short and direct response. 12.17. In the year 2012, what is the difference between the % of GDP in Angola and % of GDP in Spain?
Offer a very short reply. 9.28. In the year 2012, what is the difference between the % of GDP of Belgium and % of GDP of Madagascar?
Your answer should be compact. 5.86. In the year 2012, what is the difference between the % of GDP of Belgium and % of GDP of Spain?
Keep it short and to the point. 2.96. In the year 2012, what is the difference between the % of GDP of Madagascar and % of GDP of Spain?
Your response must be concise. -2.9. In the year 2013, what is the difference between the % of GDP of Angola and % of GDP of Belgium?
Provide a short and direct response. 1.41. In the year 2013, what is the difference between the % of GDP of Angola and % of GDP of Madagascar?
Ensure brevity in your answer.  7.94. In the year 2013, what is the difference between the % of GDP of Angola and % of GDP of Spain?
Provide a succinct answer. 4.38. In the year 2013, what is the difference between the % of GDP in Belgium and % of GDP in Madagascar?
Your answer should be very brief. 6.53. In the year 2013, what is the difference between the % of GDP in Belgium and % of GDP in Spain?
Keep it short and to the point. 2.97. In the year 2013, what is the difference between the % of GDP of Madagascar and % of GDP of Spain?
Ensure brevity in your answer.  -3.56. What is the ratio of the % of GDP of Angola in 2006 to that in 2007?
Ensure brevity in your answer.  0.91. What is the ratio of the % of GDP of Belgium in 2006 to that in 2007?
Provide a short and direct response. 0.98. What is the ratio of the % of GDP of Madagascar in 2006 to that in 2007?
Make the answer very short. 0.85. What is the ratio of the % of GDP in Angola in 2006 to that in 2008?
Your response must be concise. 0.76. What is the ratio of the % of GDP of Belgium in 2006 to that in 2008?
Keep it short and to the point. 0.93. What is the ratio of the % of GDP of Madagascar in 2006 to that in 2008?
Your answer should be compact. 0.63. What is the ratio of the % of GDP in Spain in 2006 to that in 2008?
Provide a succinct answer. 1.06. What is the ratio of the % of GDP of Angola in 2006 to that in 2009?
Your answer should be very brief. 0.56. What is the ratio of the % of GDP of Belgium in 2006 to that in 2009?
Your answer should be compact. 1.1. What is the ratio of the % of GDP in Madagascar in 2006 to that in 2009?
Give a very brief answer. 0.73. What is the ratio of the % of GDP in Spain in 2006 to that in 2009?
Make the answer very short. 1.27. What is the ratio of the % of GDP of Angola in 2006 to that in 2010?
Your answer should be very brief. 0.8. What is the ratio of the % of GDP in Belgium in 2006 to that in 2010?
Make the answer very short. 1.05. What is the ratio of the % of GDP of Madagascar in 2006 to that in 2010?
Offer a very short reply. 1.22. What is the ratio of the % of GDP in Spain in 2006 to that in 2010?
Offer a very short reply. 1.33. What is the ratio of the % of GDP in Angola in 2006 to that in 2011?
Offer a very short reply. 0.83. What is the ratio of the % of GDP in Madagascar in 2006 to that in 2011?
Provide a succinct answer. 1.44. What is the ratio of the % of GDP of Spain in 2006 to that in 2011?
Offer a very short reply. 1.43. What is the ratio of the % of GDP of Angola in 2006 to that in 2012?
Give a very brief answer. 0.79. What is the ratio of the % of GDP in Belgium in 2006 to that in 2012?
Your answer should be very brief. 1.03. What is the ratio of the % of GDP in Madagascar in 2006 to that in 2012?
Offer a terse response. 1.46. What is the ratio of the % of GDP in Spain in 2006 to that in 2012?
Offer a terse response. 1.55. What is the ratio of the % of GDP in Angola in 2006 to that in 2013?
Give a very brief answer. 0.99. What is the ratio of the % of GDP of Belgium in 2006 to that in 2013?
Your response must be concise. 1.08. What is the ratio of the % of GDP in Madagascar in 2006 to that in 2013?
Offer a terse response. 1.62. What is the ratio of the % of GDP in Spain in 2006 to that in 2013?
Make the answer very short. 1.63. What is the ratio of the % of GDP in Angola in 2007 to that in 2008?
Give a very brief answer. 0.84. What is the ratio of the % of GDP in Belgium in 2007 to that in 2008?
Offer a very short reply. 0.95. What is the ratio of the % of GDP in Madagascar in 2007 to that in 2008?
Ensure brevity in your answer.  0.73. What is the ratio of the % of GDP of Spain in 2007 to that in 2008?
Your answer should be compact. 1.06. What is the ratio of the % of GDP of Angola in 2007 to that in 2009?
Offer a terse response. 0.61. What is the ratio of the % of GDP in Belgium in 2007 to that in 2009?
Provide a short and direct response. 1.13. What is the ratio of the % of GDP in Madagascar in 2007 to that in 2009?
Keep it short and to the point. 0.85. What is the ratio of the % of GDP in Spain in 2007 to that in 2009?
Your answer should be very brief. 1.28. What is the ratio of the % of GDP of Angola in 2007 to that in 2010?
Give a very brief answer. 0.89. What is the ratio of the % of GDP of Belgium in 2007 to that in 2010?
Offer a very short reply. 1.08. What is the ratio of the % of GDP of Madagascar in 2007 to that in 2010?
Give a very brief answer. 1.43. What is the ratio of the % of GDP of Spain in 2007 to that in 2010?
Give a very brief answer. 1.33. What is the ratio of the % of GDP in Angola in 2007 to that in 2011?
Your response must be concise. 0.91. What is the ratio of the % of GDP in Belgium in 2007 to that in 2011?
Offer a terse response. 1.02. What is the ratio of the % of GDP of Madagascar in 2007 to that in 2011?
Offer a very short reply. 1.68. What is the ratio of the % of GDP in Spain in 2007 to that in 2011?
Give a very brief answer. 1.43. What is the ratio of the % of GDP of Angola in 2007 to that in 2012?
Provide a short and direct response. 0.87. What is the ratio of the % of GDP in Belgium in 2007 to that in 2012?
Your response must be concise. 1.05. What is the ratio of the % of GDP of Madagascar in 2007 to that in 2012?
Ensure brevity in your answer.  1.71. What is the ratio of the % of GDP in Spain in 2007 to that in 2012?
Offer a terse response. 1.55. What is the ratio of the % of GDP in Angola in 2007 to that in 2013?
Your answer should be compact. 1.09. What is the ratio of the % of GDP in Belgium in 2007 to that in 2013?
Your answer should be very brief. 1.11. What is the ratio of the % of GDP of Madagascar in 2007 to that in 2013?
Offer a very short reply. 1.9. What is the ratio of the % of GDP of Spain in 2007 to that in 2013?
Provide a short and direct response. 1.64. What is the ratio of the % of GDP of Angola in 2008 to that in 2009?
Make the answer very short. 0.73. What is the ratio of the % of GDP in Belgium in 2008 to that in 2009?
Provide a short and direct response. 1.19. What is the ratio of the % of GDP in Madagascar in 2008 to that in 2009?
Provide a short and direct response. 1.16. What is the ratio of the % of GDP in Spain in 2008 to that in 2009?
Ensure brevity in your answer.  1.2. What is the ratio of the % of GDP of Angola in 2008 to that in 2010?
Your answer should be compact. 1.06. What is the ratio of the % of GDP in Belgium in 2008 to that in 2010?
Ensure brevity in your answer.  1.13. What is the ratio of the % of GDP of Madagascar in 2008 to that in 2010?
Your response must be concise. 1.94. What is the ratio of the % of GDP in Spain in 2008 to that in 2010?
Your answer should be compact. 1.26. What is the ratio of the % of GDP in Angola in 2008 to that in 2011?
Offer a very short reply. 1.09. What is the ratio of the % of GDP of Belgium in 2008 to that in 2011?
Your answer should be compact. 1.07. What is the ratio of the % of GDP in Madagascar in 2008 to that in 2011?
Offer a terse response. 2.29. What is the ratio of the % of GDP in Spain in 2008 to that in 2011?
Provide a succinct answer. 1.35. What is the ratio of the % of GDP in Angola in 2008 to that in 2012?
Provide a succinct answer. 1.04. What is the ratio of the % of GDP in Belgium in 2008 to that in 2012?
Provide a succinct answer. 1.11. What is the ratio of the % of GDP of Madagascar in 2008 to that in 2012?
Keep it short and to the point. 2.33. What is the ratio of the % of GDP in Spain in 2008 to that in 2012?
Offer a terse response. 1.46. What is the ratio of the % of GDP in Angola in 2008 to that in 2013?
Provide a short and direct response. 1.31. What is the ratio of the % of GDP of Belgium in 2008 to that in 2013?
Offer a very short reply. 1.16. What is the ratio of the % of GDP of Madagascar in 2008 to that in 2013?
Provide a short and direct response. 2.59. What is the ratio of the % of GDP of Spain in 2008 to that in 2013?
Your answer should be very brief. 1.55. What is the ratio of the % of GDP of Angola in 2009 to that in 2010?
Make the answer very short. 1.45. What is the ratio of the % of GDP of Belgium in 2009 to that in 2010?
Give a very brief answer. 0.95. What is the ratio of the % of GDP of Madagascar in 2009 to that in 2010?
Your answer should be compact. 1.67. What is the ratio of the % of GDP of Spain in 2009 to that in 2010?
Offer a terse response. 1.04. What is the ratio of the % of GDP in Angola in 2009 to that in 2011?
Make the answer very short. 1.49. What is the ratio of the % of GDP in Belgium in 2009 to that in 2011?
Offer a terse response. 0.9. What is the ratio of the % of GDP of Madagascar in 2009 to that in 2011?
Provide a succinct answer. 1.97. What is the ratio of the % of GDP of Spain in 2009 to that in 2011?
Give a very brief answer. 1.12. What is the ratio of the % of GDP in Angola in 2009 to that in 2012?
Keep it short and to the point. 1.42. What is the ratio of the % of GDP in Belgium in 2009 to that in 2012?
Your answer should be compact. 0.93. What is the ratio of the % of GDP of Madagascar in 2009 to that in 2012?
Provide a short and direct response. 2.01. What is the ratio of the % of GDP in Spain in 2009 to that in 2012?
Your answer should be very brief. 1.21. What is the ratio of the % of GDP in Angola in 2009 to that in 2013?
Your answer should be compact. 1.78. What is the ratio of the % of GDP in Belgium in 2009 to that in 2013?
Provide a succinct answer. 0.98. What is the ratio of the % of GDP in Madagascar in 2009 to that in 2013?
Make the answer very short. 2.23. What is the ratio of the % of GDP in Spain in 2009 to that in 2013?
Make the answer very short. 1.28. What is the ratio of the % of GDP in Angola in 2010 to that in 2011?
Provide a succinct answer. 1.03. What is the ratio of the % of GDP in Belgium in 2010 to that in 2011?
Your response must be concise. 0.95. What is the ratio of the % of GDP in Madagascar in 2010 to that in 2011?
Your answer should be compact. 1.18. What is the ratio of the % of GDP of Spain in 2010 to that in 2011?
Ensure brevity in your answer.  1.07. What is the ratio of the % of GDP of Angola in 2010 to that in 2012?
Make the answer very short. 0.98. What is the ratio of the % of GDP of Belgium in 2010 to that in 2012?
Provide a succinct answer. 0.98. What is the ratio of the % of GDP of Madagascar in 2010 to that in 2012?
Give a very brief answer. 1.2. What is the ratio of the % of GDP in Spain in 2010 to that in 2012?
Offer a terse response. 1.16. What is the ratio of the % of GDP in Angola in 2010 to that in 2013?
Offer a very short reply. 1.23. What is the ratio of the % of GDP of Madagascar in 2010 to that in 2013?
Provide a short and direct response. 1.33. What is the ratio of the % of GDP in Spain in 2010 to that in 2013?
Offer a very short reply. 1.23. What is the ratio of the % of GDP in Angola in 2011 to that in 2012?
Your answer should be compact. 0.95. What is the ratio of the % of GDP of Belgium in 2011 to that in 2012?
Your answer should be very brief. 1.03. What is the ratio of the % of GDP in Madagascar in 2011 to that in 2012?
Give a very brief answer. 1.02. What is the ratio of the % of GDP in Spain in 2011 to that in 2012?
Your answer should be compact. 1.08. What is the ratio of the % of GDP in Angola in 2011 to that in 2013?
Your answer should be very brief. 1.2. What is the ratio of the % of GDP in Belgium in 2011 to that in 2013?
Offer a very short reply. 1.08. What is the ratio of the % of GDP of Madagascar in 2011 to that in 2013?
Provide a short and direct response. 1.13. What is the ratio of the % of GDP of Spain in 2011 to that in 2013?
Offer a terse response. 1.14. What is the ratio of the % of GDP of Angola in 2012 to that in 2013?
Offer a terse response. 1.25. What is the ratio of the % of GDP of Belgium in 2012 to that in 2013?
Make the answer very short. 1.05. What is the ratio of the % of GDP of Madagascar in 2012 to that in 2013?
Your response must be concise. 1.11. What is the ratio of the % of GDP of Spain in 2012 to that in 2013?
Provide a short and direct response. 1.06. What is the difference between the highest and the second highest % of GDP in Angola?
Keep it short and to the point. 11.18. What is the difference between the highest and the second highest % of GDP of Belgium?
Keep it short and to the point. 1.28. What is the difference between the highest and the second highest % of GDP of Madagascar?
Your response must be concise. 5.55. What is the difference between the highest and the second highest % of GDP in Spain?
Ensure brevity in your answer.  0.04. What is the difference between the highest and the lowest % of GDP of Angola?
Your response must be concise. 18.68. What is the difference between the highest and the lowest % of GDP of Belgium?
Provide a succinct answer. 4.07. What is the difference between the highest and the lowest % of GDP in Madagascar?
Offer a terse response. 24.73. What is the difference between the highest and the lowest % of GDP in Spain?
Provide a succinct answer. 12.19. 